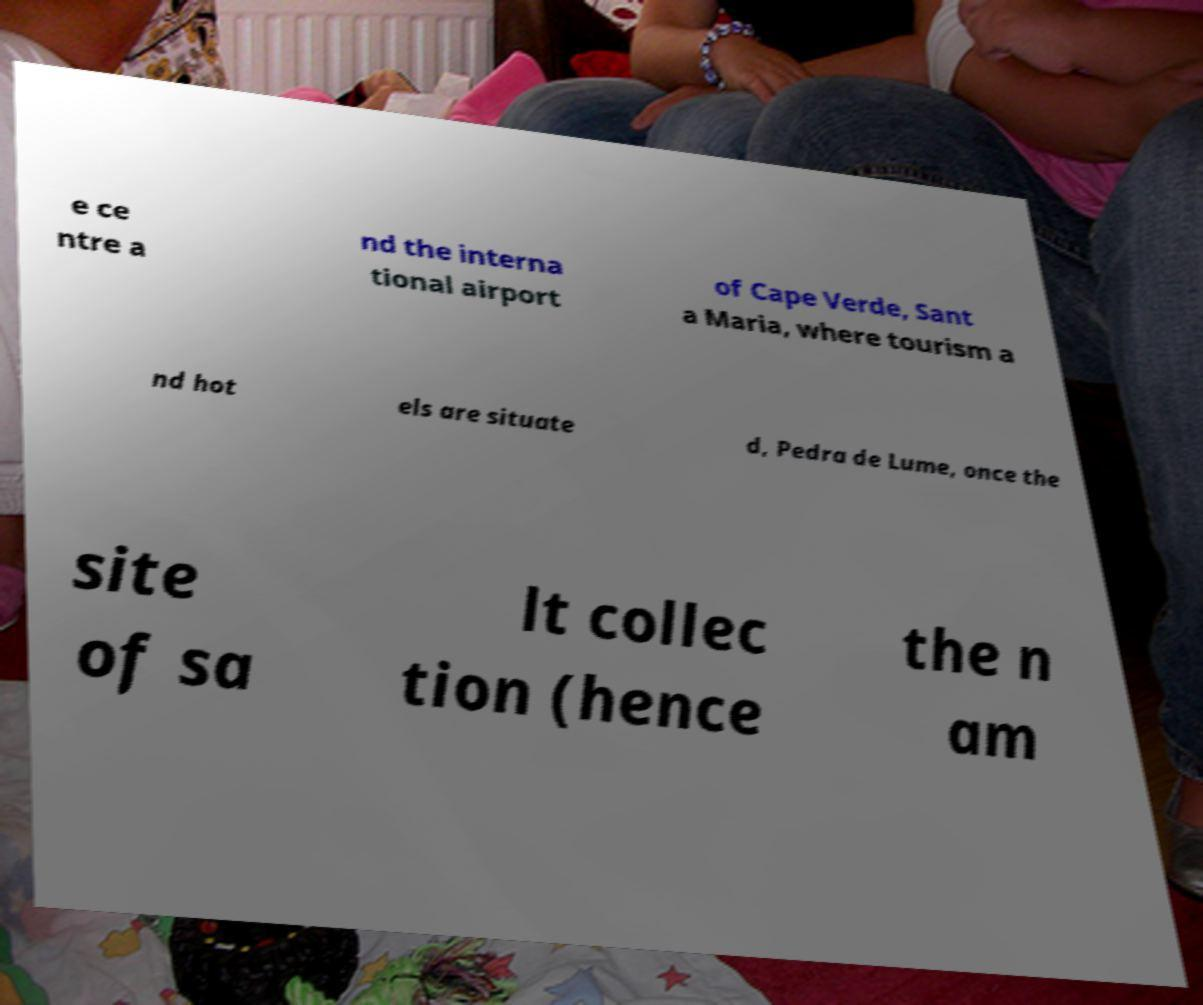Please read and relay the text visible in this image. What does it say? e ce ntre a nd the interna tional airport of Cape Verde, Sant a Maria, where tourism a nd hot els are situate d, Pedra de Lume, once the site of sa lt collec tion (hence the n am 